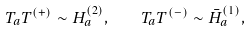Convert formula to latex. <formula><loc_0><loc_0><loc_500><loc_500>T _ { a } T ^ { ( + ) } \sim H ^ { ( 2 ) } _ { a } , \quad T _ { a } T ^ { ( - ) } \sim { \bar { H } } ^ { ( 1 ) } _ { a } ,</formula> 